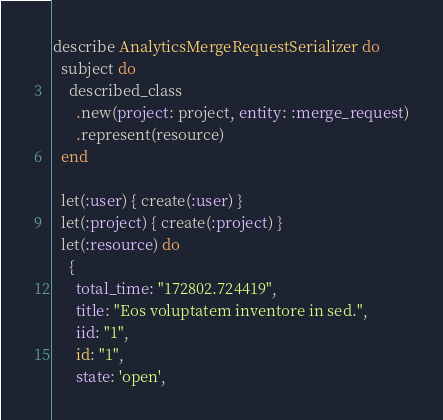Convert code to text. <code><loc_0><loc_0><loc_500><loc_500><_Ruby_>describe AnalyticsMergeRequestSerializer do
  subject do
    described_class
      .new(project: project, entity: :merge_request)
      .represent(resource)
  end

  let(:user) { create(:user) }
  let(:project) { create(:project) }
  let(:resource) do
    {
      total_time: "172802.724419",
      title: "Eos voluptatem inventore in sed.",
      iid: "1",
      id: "1",
      state: 'open',</code> 